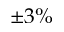<formula> <loc_0><loc_0><loc_500><loc_500>\pm 3 \%</formula> 